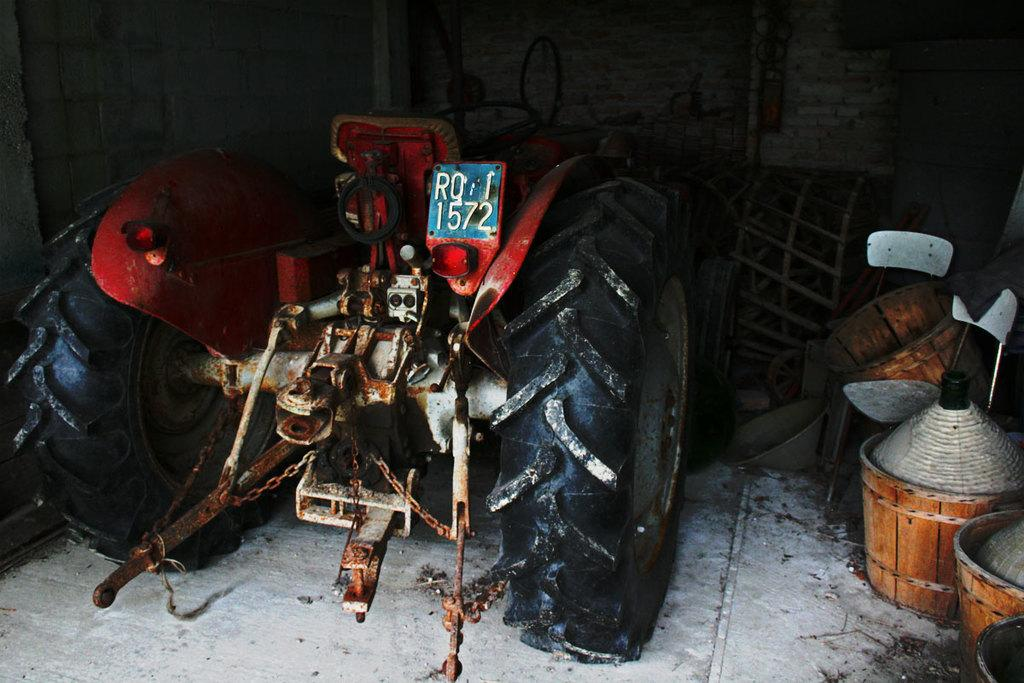What is the main subject of the image? The main subject of the image is a tractor. Are there any additional objects or items near the tractor? Yes, there are baskets beside the tractor. How do the pets react to the tractor in the image? There are no pets present in the image, so their reaction cannot be determined. 